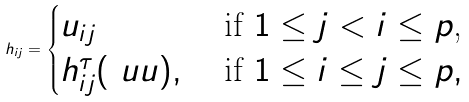Convert formula to latex. <formula><loc_0><loc_0><loc_500><loc_500>h _ { i j } = \begin{cases} u _ { i j } & \text { if $1\leq j < i \leq p$,} \\ h ^ { \tau } _ { i j } ( \ u u ) , & \text { if $1\leq i \leq j \leq p$} , \end{cases}</formula> 